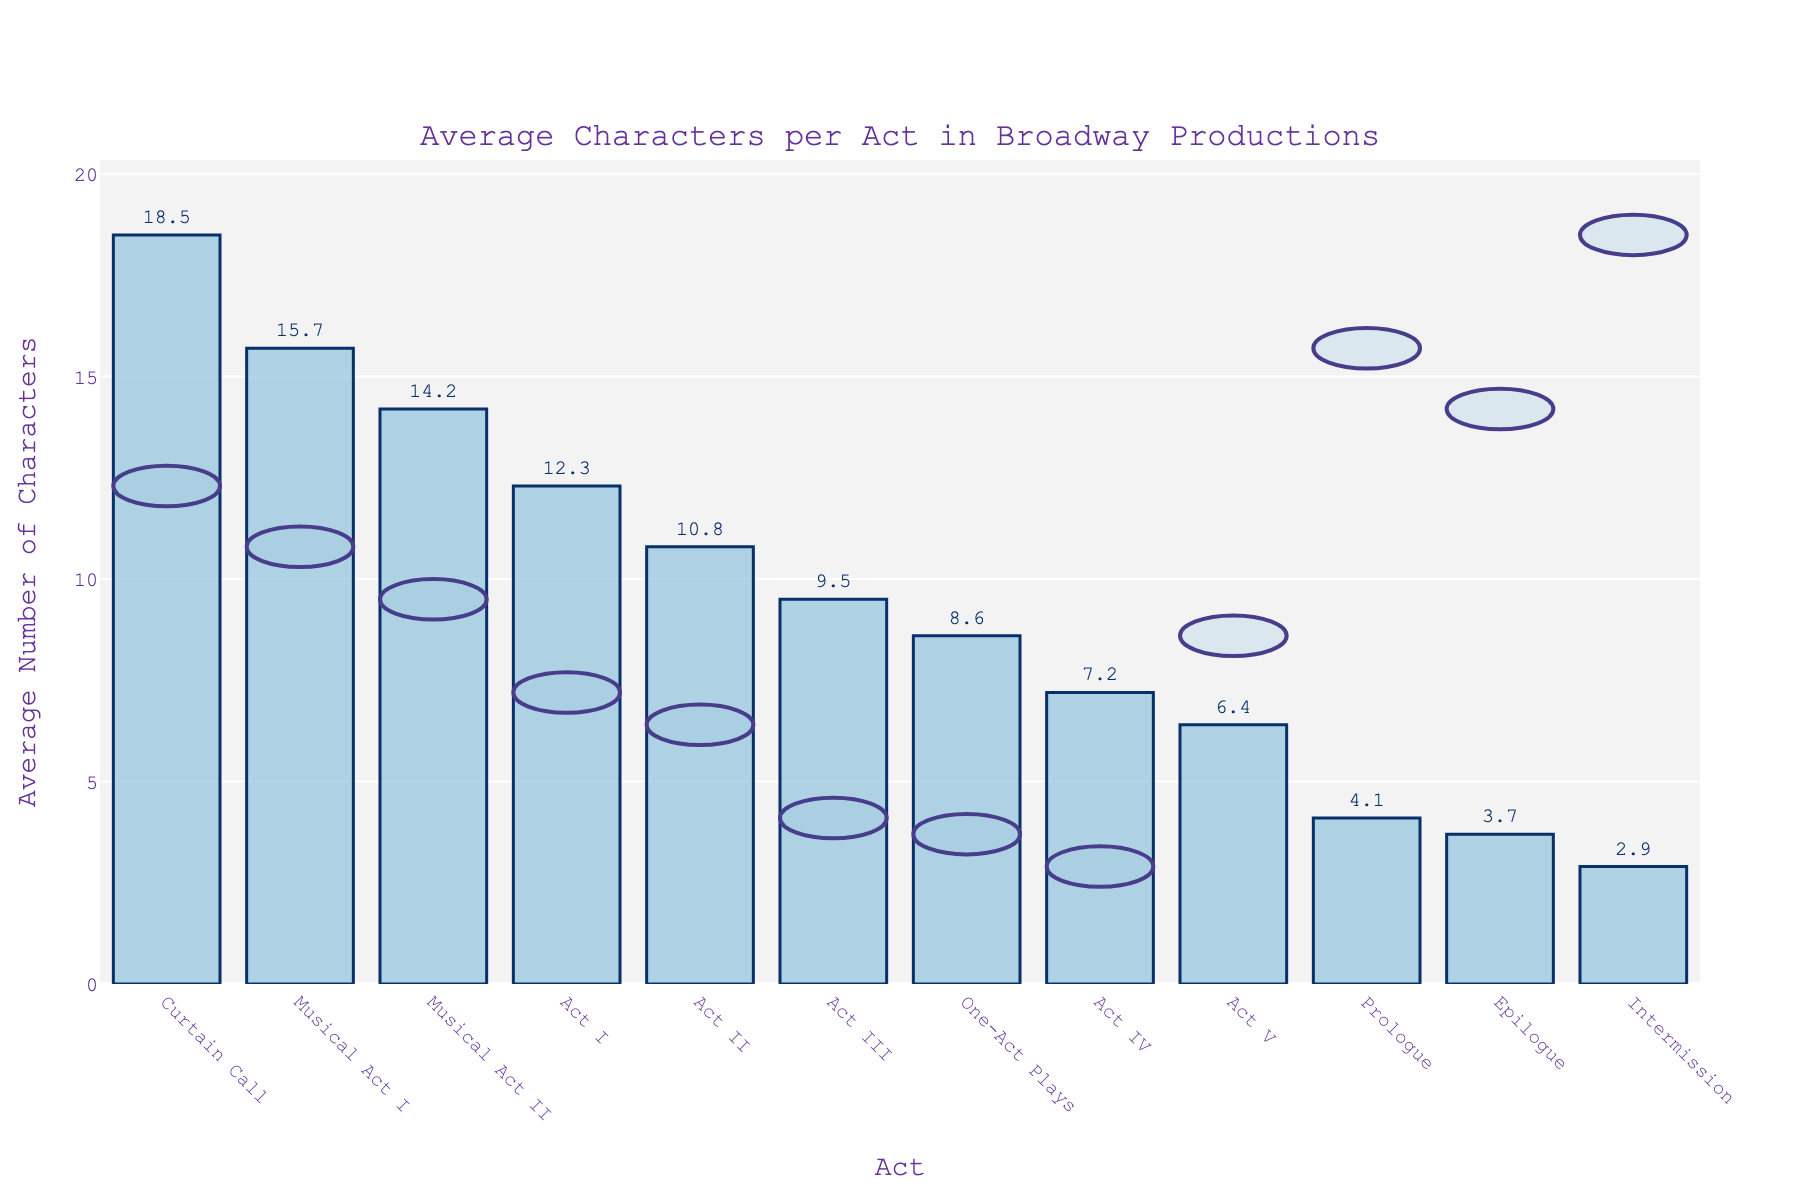Which act has the highest average number of characters? By looking at the height of the bars, we can see that the "Curtain Call" has the highest bar, indicating it has the highest average number of characters.
Answer: Curtain Call Which act has fewer average characters, Act II or One-Act Plays? By comparing the heights of the bars for Act II and One-Act Plays, it is noticeable that the bar for Act II is higher than the bar for One-Act Plays. Therefore, One-Act Plays have fewer average characters than Act II.
Answer: One-Act Plays What is the difference in the average number of characters between Act I and Act V? Refer to the heights of the bars for Act I and Act V. The bar for Act I shows 12.3 characters, while the bar for Act V shows 6.4 characters. The difference is computed as 12.3 - 6.4 = 5.9.
Answer: 5.9 Which section has the lowest number of average characters? By identifying the shortest bar in the chart, the "Intermission" section has the shortest bar, thus the lowest number of average characters.
Answer: Intermission How many more characters on average does Musical Act I have compared to Musical Act II? Looking at the bars for Musical Act I and Musical Act II, Musical Act I has 15.7 characters and Musical Act II has 14.2 characters. The difference is 15.7 - 14.2 = 1.5.
Answer: 1.5 What is the sum of the average characters in Prologue, Epilogue, and Intermission? The heights of the bars indicate the average characters for Prologue, Epilogue, and Intermission are 4.1, 3.7, and 2.9 respectively. Summing these gives 4.1 + 3.7 + 2.9 = 10.7.
Answer: 10.7 Is the average number of characters greater in Act I than in Act III? The bar for Act I is higher than the bar for Act III, indicating that Act I has more average characters than Act III.
Answer: Yes What is the range of average characters numbers represented in the bar chart? The highest average characters number is for Curtain Call (18.5) and the lowest is for Intermission (2.9). The range is calculated as 18.5 - 2.9 = 15.6.
Answer: 15.6 How many acts have more than 10 average characters? Count the number of bars that extend above 10 on the Y-axis. This includes Act I (12.3), Act II (10.8), Musical Act I (15.7), and Musical Act II (14.2). Therefore, there are 4 such acts.
Answer: 4 